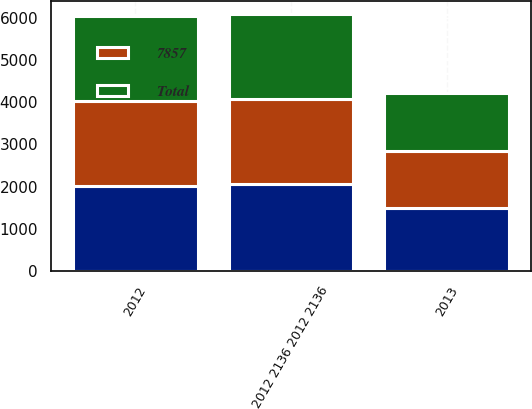Convert chart. <chart><loc_0><loc_0><loc_500><loc_500><stacked_bar_chart><ecel><fcel>2012<fcel>2012 2136 2012 2136<fcel>2013<nl><fcel>nan<fcel>2013<fcel>2056<fcel>1488<nl><fcel>7857<fcel>2015<fcel>2018<fcel>1365<nl><fcel>Total<fcel>2016<fcel>2019<fcel>1375<nl></chart> 